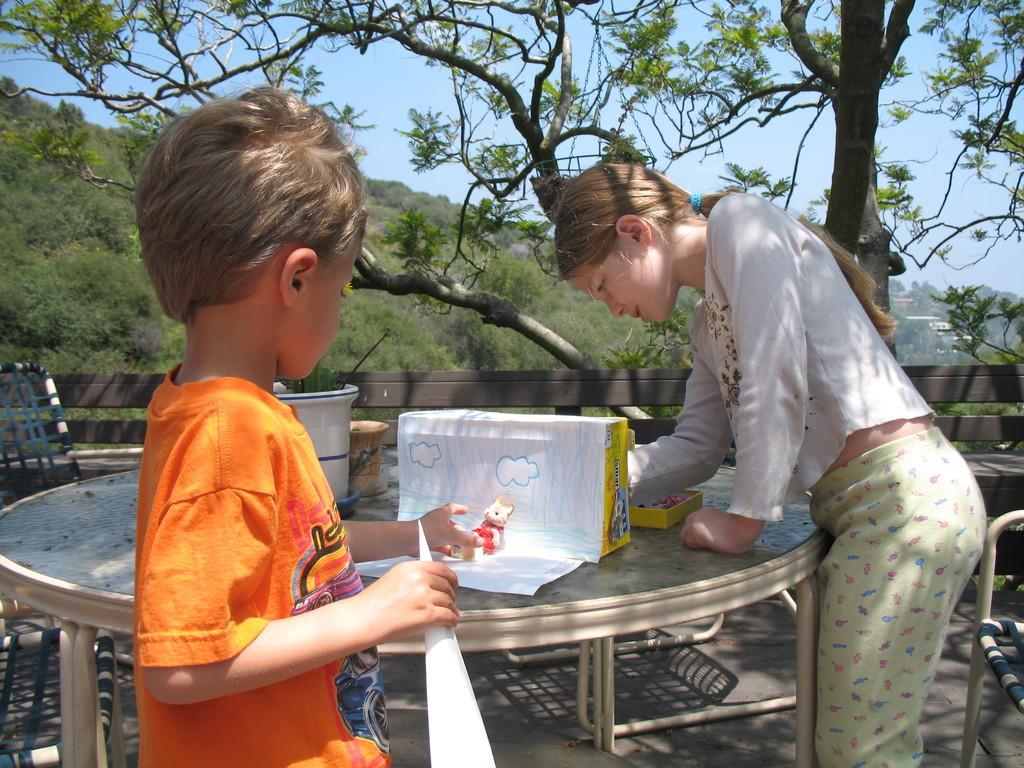Could you give a brief overview of what you see in this image? Here we can see a boy and a girl standing near a table preparing something with papers and behind them we can see trees and hills 